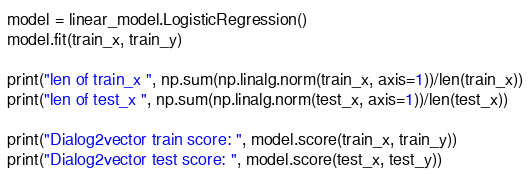<code> <loc_0><loc_0><loc_500><loc_500><_Python_>model = linear_model.LogisticRegression()
model.fit(train_x, train_y)

print("len of train_x ", np.sum(np.linalg.norm(train_x, axis=1))/len(train_x))
print("len of test_x ", np.sum(np.linalg.norm(test_x, axis=1))/len(test_x))

print("Dialog2vector train score: ", model.score(train_x, train_y))
print("Dialog2vector test score: ", model.score(test_x, test_y))
</code> 